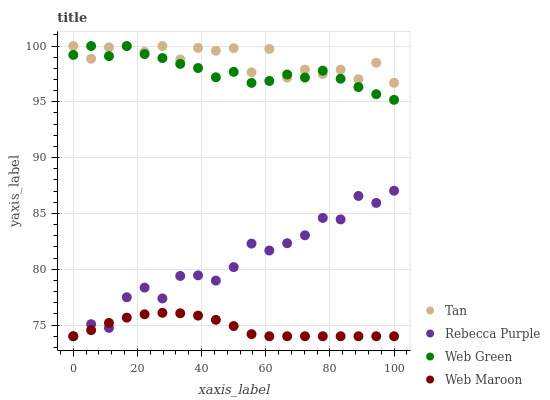Does Web Maroon have the minimum area under the curve?
Answer yes or no. Yes. Does Tan have the maximum area under the curve?
Answer yes or no. Yes. Does Rebecca Purple have the minimum area under the curve?
Answer yes or no. No. Does Rebecca Purple have the maximum area under the curve?
Answer yes or no. No. Is Web Maroon the smoothest?
Answer yes or no. Yes. Is Tan the roughest?
Answer yes or no. Yes. Is Rebecca Purple the smoothest?
Answer yes or no. No. Is Rebecca Purple the roughest?
Answer yes or no. No. Does Web Maroon have the lowest value?
Answer yes or no. Yes. Does Web Green have the lowest value?
Answer yes or no. No. Does Web Green have the highest value?
Answer yes or no. Yes. Does Rebecca Purple have the highest value?
Answer yes or no. No. Is Web Maroon less than Tan?
Answer yes or no. Yes. Is Tan greater than Rebecca Purple?
Answer yes or no. Yes. Does Web Maroon intersect Rebecca Purple?
Answer yes or no. Yes. Is Web Maroon less than Rebecca Purple?
Answer yes or no. No. Is Web Maroon greater than Rebecca Purple?
Answer yes or no. No. Does Web Maroon intersect Tan?
Answer yes or no. No. 